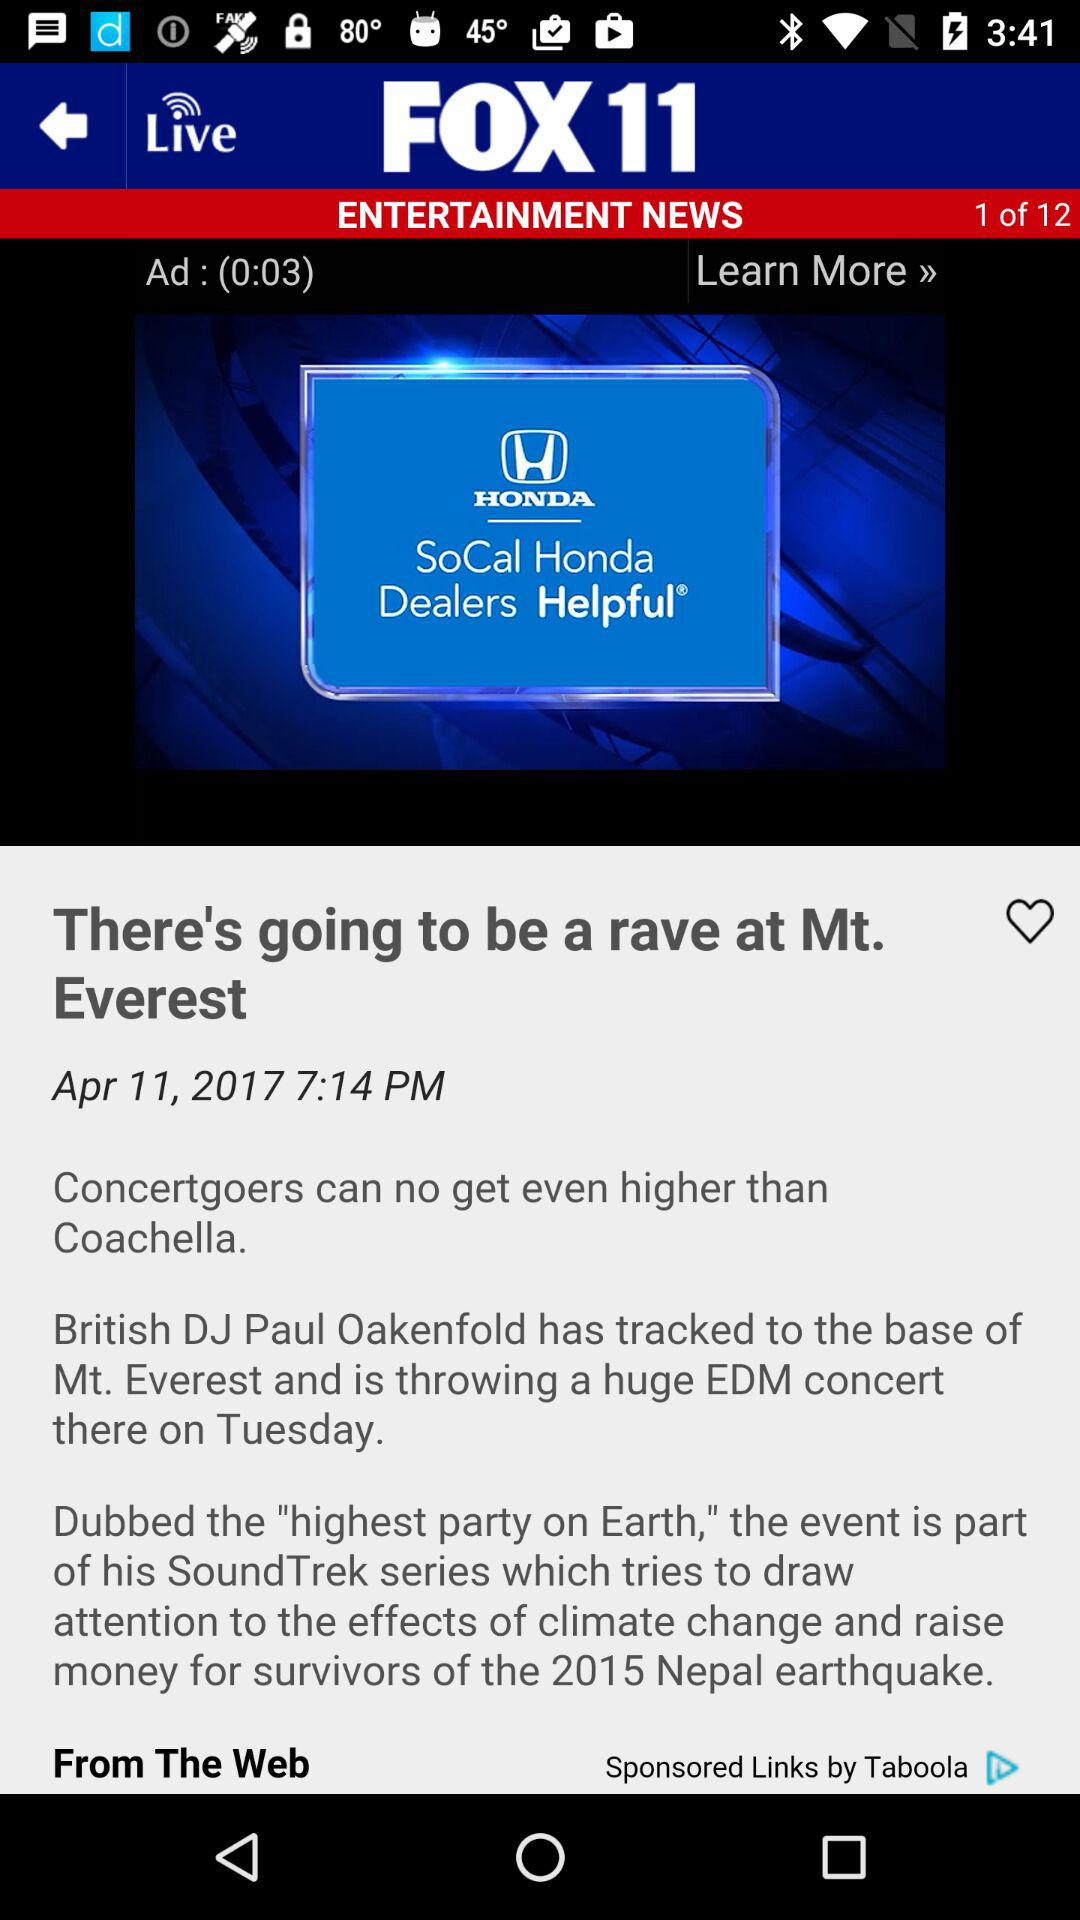What is the title of the news? The title of the news is "There's going to be a rave at Mt. Everest". 